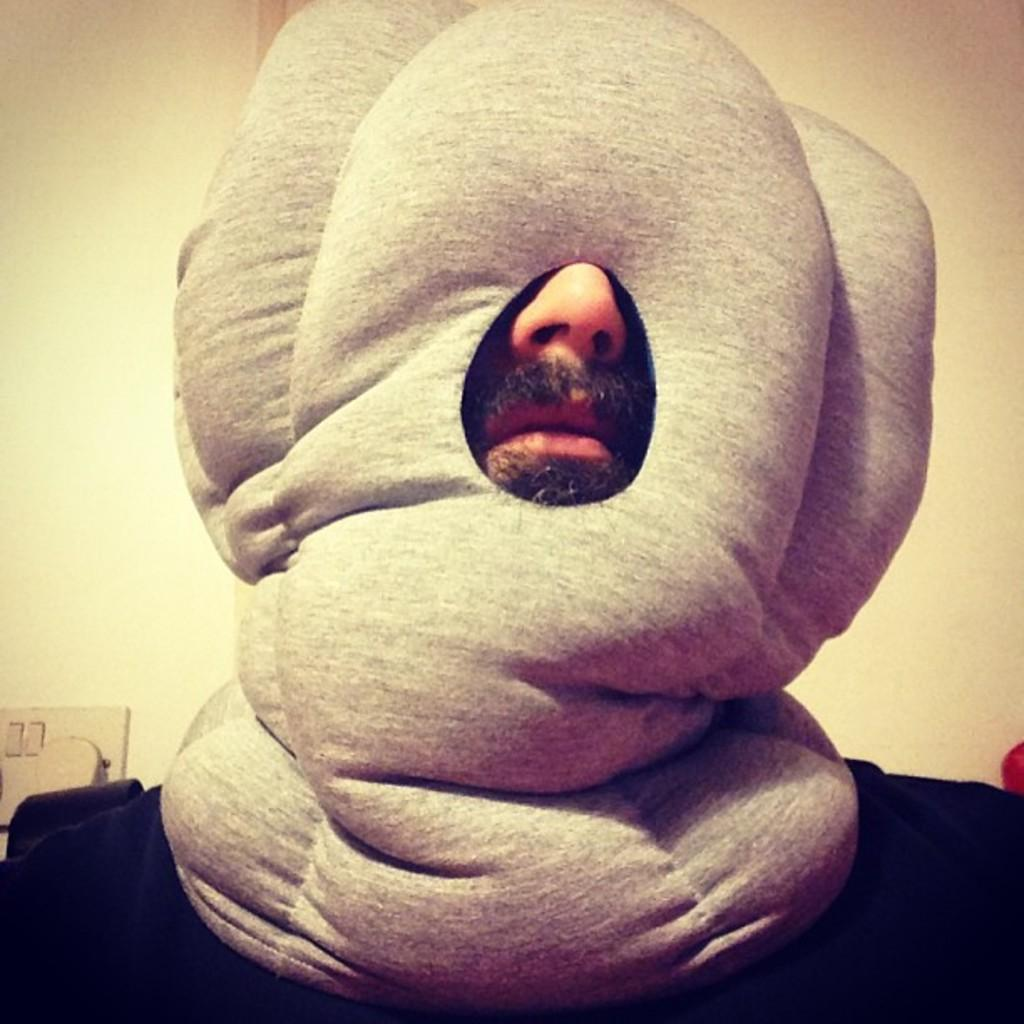What is the main subject of the image? There is a person in the image. What is the person wearing? The person is wearing a black dress and a grey face mask. What can be seen in the background of the image? There is a wall and a switch board in the background of the image. What direction is the tramp moving in the image? There is no tramp present in the image. What type of horn can be heard in the image? There is no sound or horn present in the image. 